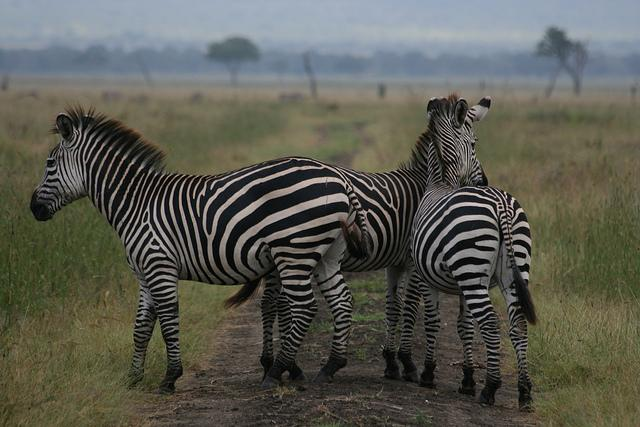How many zebras are standing in the way of the path?

Choices:
A) two
B) three
C) four
D) one three 